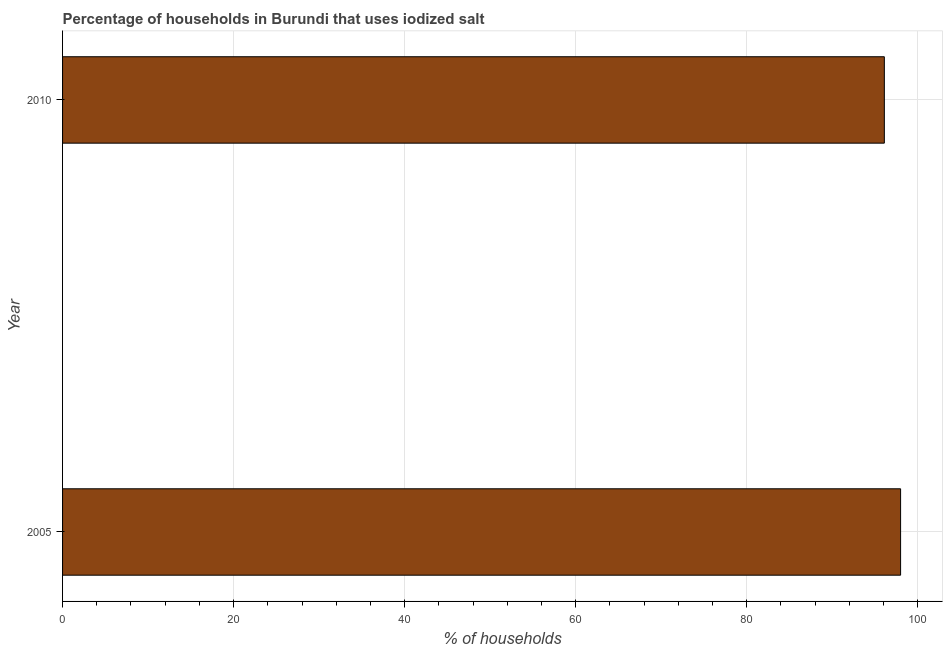Does the graph contain any zero values?
Offer a very short reply. No. What is the title of the graph?
Provide a succinct answer. Percentage of households in Burundi that uses iodized salt. What is the label or title of the X-axis?
Provide a succinct answer. % of households. What is the label or title of the Y-axis?
Offer a very short reply. Year. What is the percentage of households where iodized salt is consumed in 2005?
Your response must be concise. 98. Across all years, what is the minimum percentage of households where iodized salt is consumed?
Your answer should be very brief. 96.1. In which year was the percentage of households where iodized salt is consumed maximum?
Your answer should be very brief. 2005. In which year was the percentage of households where iodized salt is consumed minimum?
Your answer should be very brief. 2010. What is the sum of the percentage of households where iodized salt is consumed?
Your answer should be very brief. 194.1. What is the difference between the percentage of households where iodized salt is consumed in 2005 and 2010?
Your answer should be very brief. 1.9. What is the average percentage of households where iodized salt is consumed per year?
Keep it short and to the point. 97.05. What is the median percentage of households where iodized salt is consumed?
Offer a very short reply. 97.05. Do a majority of the years between 2010 and 2005 (inclusive) have percentage of households where iodized salt is consumed greater than 40 %?
Ensure brevity in your answer.  No. Is the percentage of households where iodized salt is consumed in 2005 less than that in 2010?
Make the answer very short. No. In how many years, is the percentage of households where iodized salt is consumed greater than the average percentage of households where iodized salt is consumed taken over all years?
Keep it short and to the point. 1. How many bars are there?
Your answer should be compact. 2. Are all the bars in the graph horizontal?
Offer a terse response. Yes. How many years are there in the graph?
Your answer should be compact. 2. What is the difference between two consecutive major ticks on the X-axis?
Give a very brief answer. 20. What is the % of households in 2010?
Your answer should be compact. 96.1. What is the ratio of the % of households in 2005 to that in 2010?
Your answer should be compact. 1.02. 